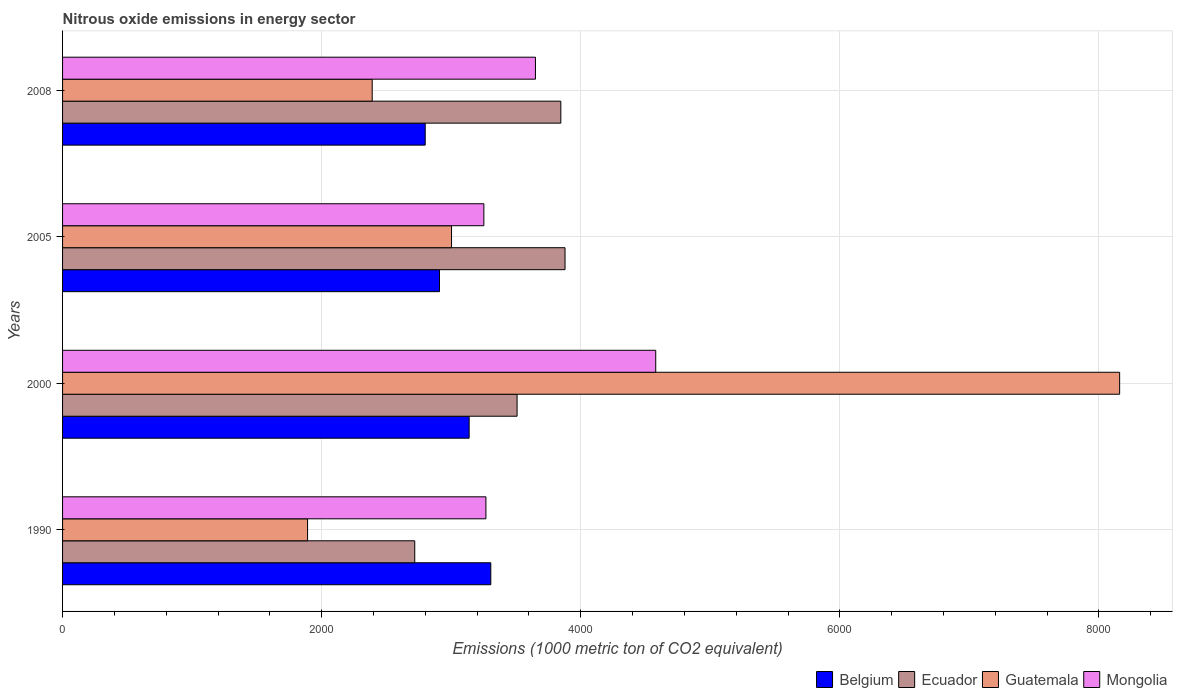How many different coloured bars are there?
Your answer should be compact. 4. How many groups of bars are there?
Provide a short and direct response. 4. Are the number of bars on each tick of the Y-axis equal?
Your response must be concise. Yes. How many bars are there on the 1st tick from the top?
Your answer should be compact. 4. What is the amount of nitrous oxide emitted in Mongolia in 2008?
Keep it short and to the point. 3650.1. Across all years, what is the maximum amount of nitrous oxide emitted in Ecuador?
Provide a short and direct response. 3878.5. Across all years, what is the minimum amount of nitrous oxide emitted in Ecuador?
Ensure brevity in your answer.  2718.5. In which year was the amount of nitrous oxide emitted in Belgium maximum?
Keep it short and to the point. 1990. In which year was the amount of nitrous oxide emitted in Mongolia minimum?
Offer a very short reply. 2005. What is the total amount of nitrous oxide emitted in Belgium in the graph?
Offer a very short reply. 1.22e+04. What is the difference between the amount of nitrous oxide emitted in Mongolia in 1990 and that in 2005?
Provide a short and direct response. 15.9. What is the difference between the amount of nitrous oxide emitted in Ecuador in 2005 and the amount of nitrous oxide emitted in Guatemala in 2000?
Offer a very short reply. -4280.9. What is the average amount of nitrous oxide emitted in Guatemala per year?
Your answer should be compact. 3860.75. In the year 2005, what is the difference between the amount of nitrous oxide emitted in Belgium and amount of nitrous oxide emitted in Guatemala?
Ensure brevity in your answer.  -93. What is the ratio of the amount of nitrous oxide emitted in Guatemala in 2000 to that in 2005?
Provide a succinct answer. 2.72. What is the difference between the highest and the second highest amount of nitrous oxide emitted in Mongolia?
Keep it short and to the point. 928.5. What is the difference between the highest and the lowest amount of nitrous oxide emitted in Guatemala?
Your answer should be compact. 6268.2. Is the sum of the amount of nitrous oxide emitted in Ecuador in 1990 and 2005 greater than the maximum amount of nitrous oxide emitted in Belgium across all years?
Your response must be concise. Yes. What does the 2nd bar from the top in 2005 represents?
Give a very brief answer. Guatemala. What does the 2nd bar from the bottom in 2008 represents?
Offer a very short reply. Ecuador. How many bars are there?
Your answer should be compact. 16. How many years are there in the graph?
Provide a succinct answer. 4. What is the difference between two consecutive major ticks on the X-axis?
Ensure brevity in your answer.  2000. Where does the legend appear in the graph?
Offer a very short reply. Bottom right. How many legend labels are there?
Make the answer very short. 4. What is the title of the graph?
Offer a terse response. Nitrous oxide emissions in energy sector. Does "Heavily indebted poor countries" appear as one of the legend labels in the graph?
Your answer should be very brief. No. What is the label or title of the X-axis?
Give a very brief answer. Emissions (1000 metric ton of CO2 equivalent). What is the Emissions (1000 metric ton of CO2 equivalent) of Belgium in 1990?
Keep it short and to the point. 3305.4. What is the Emissions (1000 metric ton of CO2 equivalent) of Ecuador in 1990?
Provide a succinct answer. 2718.5. What is the Emissions (1000 metric ton of CO2 equivalent) in Guatemala in 1990?
Your answer should be compact. 1891.2. What is the Emissions (1000 metric ton of CO2 equivalent) of Mongolia in 1990?
Your answer should be very brief. 3267.8. What is the Emissions (1000 metric ton of CO2 equivalent) in Belgium in 2000?
Ensure brevity in your answer.  3138.4. What is the Emissions (1000 metric ton of CO2 equivalent) of Ecuador in 2000?
Offer a very short reply. 3508.3. What is the Emissions (1000 metric ton of CO2 equivalent) of Guatemala in 2000?
Your response must be concise. 8159.4. What is the Emissions (1000 metric ton of CO2 equivalent) in Mongolia in 2000?
Your answer should be compact. 4578.6. What is the Emissions (1000 metric ton of CO2 equivalent) in Belgium in 2005?
Keep it short and to the point. 2909.4. What is the Emissions (1000 metric ton of CO2 equivalent) in Ecuador in 2005?
Keep it short and to the point. 3878.5. What is the Emissions (1000 metric ton of CO2 equivalent) of Guatemala in 2005?
Your response must be concise. 3002.4. What is the Emissions (1000 metric ton of CO2 equivalent) of Mongolia in 2005?
Keep it short and to the point. 3251.9. What is the Emissions (1000 metric ton of CO2 equivalent) of Belgium in 2008?
Your answer should be very brief. 2799.3. What is the Emissions (1000 metric ton of CO2 equivalent) in Ecuador in 2008?
Offer a very short reply. 3846. What is the Emissions (1000 metric ton of CO2 equivalent) in Guatemala in 2008?
Your answer should be very brief. 2390. What is the Emissions (1000 metric ton of CO2 equivalent) in Mongolia in 2008?
Your answer should be very brief. 3650.1. Across all years, what is the maximum Emissions (1000 metric ton of CO2 equivalent) in Belgium?
Offer a terse response. 3305.4. Across all years, what is the maximum Emissions (1000 metric ton of CO2 equivalent) of Ecuador?
Make the answer very short. 3878.5. Across all years, what is the maximum Emissions (1000 metric ton of CO2 equivalent) of Guatemala?
Your response must be concise. 8159.4. Across all years, what is the maximum Emissions (1000 metric ton of CO2 equivalent) of Mongolia?
Your answer should be compact. 4578.6. Across all years, what is the minimum Emissions (1000 metric ton of CO2 equivalent) of Belgium?
Your answer should be very brief. 2799.3. Across all years, what is the minimum Emissions (1000 metric ton of CO2 equivalent) in Ecuador?
Offer a terse response. 2718.5. Across all years, what is the minimum Emissions (1000 metric ton of CO2 equivalent) in Guatemala?
Your answer should be very brief. 1891.2. Across all years, what is the minimum Emissions (1000 metric ton of CO2 equivalent) in Mongolia?
Your answer should be very brief. 3251.9. What is the total Emissions (1000 metric ton of CO2 equivalent) of Belgium in the graph?
Ensure brevity in your answer.  1.22e+04. What is the total Emissions (1000 metric ton of CO2 equivalent) in Ecuador in the graph?
Provide a short and direct response. 1.40e+04. What is the total Emissions (1000 metric ton of CO2 equivalent) in Guatemala in the graph?
Make the answer very short. 1.54e+04. What is the total Emissions (1000 metric ton of CO2 equivalent) of Mongolia in the graph?
Provide a short and direct response. 1.47e+04. What is the difference between the Emissions (1000 metric ton of CO2 equivalent) in Belgium in 1990 and that in 2000?
Provide a succinct answer. 167. What is the difference between the Emissions (1000 metric ton of CO2 equivalent) of Ecuador in 1990 and that in 2000?
Give a very brief answer. -789.8. What is the difference between the Emissions (1000 metric ton of CO2 equivalent) of Guatemala in 1990 and that in 2000?
Your answer should be very brief. -6268.2. What is the difference between the Emissions (1000 metric ton of CO2 equivalent) in Mongolia in 1990 and that in 2000?
Provide a short and direct response. -1310.8. What is the difference between the Emissions (1000 metric ton of CO2 equivalent) in Belgium in 1990 and that in 2005?
Offer a terse response. 396. What is the difference between the Emissions (1000 metric ton of CO2 equivalent) of Ecuador in 1990 and that in 2005?
Provide a short and direct response. -1160. What is the difference between the Emissions (1000 metric ton of CO2 equivalent) of Guatemala in 1990 and that in 2005?
Your answer should be very brief. -1111.2. What is the difference between the Emissions (1000 metric ton of CO2 equivalent) of Mongolia in 1990 and that in 2005?
Your answer should be very brief. 15.9. What is the difference between the Emissions (1000 metric ton of CO2 equivalent) in Belgium in 1990 and that in 2008?
Your answer should be very brief. 506.1. What is the difference between the Emissions (1000 metric ton of CO2 equivalent) of Ecuador in 1990 and that in 2008?
Offer a very short reply. -1127.5. What is the difference between the Emissions (1000 metric ton of CO2 equivalent) in Guatemala in 1990 and that in 2008?
Ensure brevity in your answer.  -498.8. What is the difference between the Emissions (1000 metric ton of CO2 equivalent) of Mongolia in 1990 and that in 2008?
Your response must be concise. -382.3. What is the difference between the Emissions (1000 metric ton of CO2 equivalent) in Belgium in 2000 and that in 2005?
Ensure brevity in your answer.  229. What is the difference between the Emissions (1000 metric ton of CO2 equivalent) of Ecuador in 2000 and that in 2005?
Offer a very short reply. -370.2. What is the difference between the Emissions (1000 metric ton of CO2 equivalent) of Guatemala in 2000 and that in 2005?
Give a very brief answer. 5157. What is the difference between the Emissions (1000 metric ton of CO2 equivalent) of Mongolia in 2000 and that in 2005?
Your answer should be very brief. 1326.7. What is the difference between the Emissions (1000 metric ton of CO2 equivalent) of Belgium in 2000 and that in 2008?
Your response must be concise. 339.1. What is the difference between the Emissions (1000 metric ton of CO2 equivalent) in Ecuador in 2000 and that in 2008?
Your response must be concise. -337.7. What is the difference between the Emissions (1000 metric ton of CO2 equivalent) of Guatemala in 2000 and that in 2008?
Keep it short and to the point. 5769.4. What is the difference between the Emissions (1000 metric ton of CO2 equivalent) of Mongolia in 2000 and that in 2008?
Offer a terse response. 928.5. What is the difference between the Emissions (1000 metric ton of CO2 equivalent) of Belgium in 2005 and that in 2008?
Offer a terse response. 110.1. What is the difference between the Emissions (1000 metric ton of CO2 equivalent) in Ecuador in 2005 and that in 2008?
Give a very brief answer. 32.5. What is the difference between the Emissions (1000 metric ton of CO2 equivalent) of Guatemala in 2005 and that in 2008?
Give a very brief answer. 612.4. What is the difference between the Emissions (1000 metric ton of CO2 equivalent) of Mongolia in 2005 and that in 2008?
Provide a succinct answer. -398.2. What is the difference between the Emissions (1000 metric ton of CO2 equivalent) in Belgium in 1990 and the Emissions (1000 metric ton of CO2 equivalent) in Ecuador in 2000?
Your answer should be very brief. -202.9. What is the difference between the Emissions (1000 metric ton of CO2 equivalent) of Belgium in 1990 and the Emissions (1000 metric ton of CO2 equivalent) of Guatemala in 2000?
Offer a very short reply. -4854. What is the difference between the Emissions (1000 metric ton of CO2 equivalent) in Belgium in 1990 and the Emissions (1000 metric ton of CO2 equivalent) in Mongolia in 2000?
Ensure brevity in your answer.  -1273.2. What is the difference between the Emissions (1000 metric ton of CO2 equivalent) of Ecuador in 1990 and the Emissions (1000 metric ton of CO2 equivalent) of Guatemala in 2000?
Your answer should be very brief. -5440.9. What is the difference between the Emissions (1000 metric ton of CO2 equivalent) of Ecuador in 1990 and the Emissions (1000 metric ton of CO2 equivalent) of Mongolia in 2000?
Provide a succinct answer. -1860.1. What is the difference between the Emissions (1000 metric ton of CO2 equivalent) in Guatemala in 1990 and the Emissions (1000 metric ton of CO2 equivalent) in Mongolia in 2000?
Offer a terse response. -2687.4. What is the difference between the Emissions (1000 metric ton of CO2 equivalent) of Belgium in 1990 and the Emissions (1000 metric ton of CO2 equivalent) of Ecuador in 2005?
Give a very brief answer. -573.1. What is the difference between the Emissions (1000 metric ton of CO2 equivalent) of Belgium in 1990 and the Emissions (1000 metric ton of CO2 equivalent) of Guatemala in 2005?
Offer a terse response. 303. What is the difference between the Emissions (1000 metric ton of CO2 equivalent) of Belgium in 1990 and the Emissions (1000 metric ton of CO2 equivalent) of Mongolia in 2005?
Your response must be concise. 53.5. What is the difference between the Emissions (1000 metric ton of CO2 equivalent) in Ecuador in 1990 and the Emissions (1000 metric ton of CO2 equivalent) in Guatemala in 2005?
Make the answer very short. -283.9. What is the difference between the Emissions (1000 metric ton of CO2 equivalent) of Ecuador in 1990 and the Emissions (1000 metric ton of CO2 equivalent) of Mongolia in 2005?
Keep it short and to the point. -533.4. What is the difference between the Emissions (1000 metric ton of CO2 equivalent) in Guatemala in 1990 and the Emissions (1000 metric ton of CO2 equivalent) in Mongolia in 2005?
Offer a terse response. -1360.7. What is the difference between the Emissions (1000 metric ton of CO2 equivalent) in Belgium in 1990 and the Emissions (1000 metric ton of CO2 equivalent) in Ecuador in 2008?
Offer a terse response. -540.6. What is the difference between the Emissions (1000 metric ton of CO2 equivalent) in Belgium in 1990 and the Emissions (1000 metric ton of CO2 equivalent) in Guatemala in 2008?
Offer a terse response. 915.4. What is the difference between the Emissions (1000 metric ton of CO2 equivalent) of Belgium in 1990 and the Emissions (1000 metric ton of CO2 equivalent) of Mongolia in 2008?
Provide a succinct answer. -344.7. What is the difference between the Emissions (1000 metric ton of CO2 equivalent) of Ecuador in 1990 and the Emissions (1000 metric ton of CO2 equivalent) of Guatemala in 2008?
Ensure brevity in your answer.  328.5. What is the difference between the Emissions (1000 metric ton of CO2 equivalent) of Ecuador in 1990 and the Emissions (1000 metric ton of CO2 equivalent) of Mongolia in 2008?
Your answer should be very brief. -931.6. What is the difference between the Emissions (1000 metric ton of CO2 equivalent) of Guatemala in 1990 and the Emissions (1000 metric ton of CO2 equivalent) of Mongolia in 2008?
Provide a short and direct response. -1758.9. What is the difference between the Emissions (1000 metric ton of CO2 equivalent) of Belgium in 2000 and the Emissions (1000 metric ton of CO2 equivalent) of Ecuador in 2005?
Provide a succinct answer. -740.1. What is the difference between the Emissions (1000 metric ton of CO2 equivalent) of Belgium in 2000 and the Emissions (1000 metric ton of CO2 equivalent) of Guatemala in 2005?
Offer a very short reply. 136. What is the difference between the Emissions (1000 metric ton of CO2 equivalent) in Belgium in 2000 and the Emissions (1000 metric ton of CO2 equivalent) in Mongolia in 2005?
Provide a short and direct response. -113.5. What is the difference between the Emissions (1000 metric ton of CO2 equivalent) of Ecuador in 2000 and the Emissions (1000 metric ton of CO2 equivalent) of Guatemala in 2005?
Your answer should be compact. 505.9. What is the difference between the Emissions (1000 metric ton of CO2 equivalent) of Ecuador in 2000 and the Emissions (1000 metric ton of CO2 equivalent) of Mongolia in 2005?
Provide a succinct answer. 256.4. What is the difference between the Emissions (1000 metric ton of CO2 equivalent) in Guatemala in 2000 and the Emissions (1000 metric ton of CO2 equivalent) in Mongolia in 2005?
Your answer should be compact. 4907.5. What is the difference between the Emissions (1000 metric ton of CO2 equivalent) of Belgium in 2000 and the Emissions (1000 metric ton of CO2 equivalent) of Ecuador in 2008?
Provide a succinct answer. -707.6. What is the difference between the Emissions (1000 metric ton of CO2 equivalent) in Belgium in 2000 and the Emissions (1000 metric ton of CO2 equivalent) in Guatemala in 2008?
Your response must be concise. 748.4. What is the difference between the Emissions (1000 metric ton of CO2 equivalent) of Belgium in 2000 and the Emissions (1000 metric ton of CO2 equivalent) of Mongolia in 2008?
Offer a terse response. -511.7. What is the difference between the Emissions (1000 metric ton of CO2 equivalent) in Ecuador in 2000 and the Emissions (1000 metric ton of CO2 equivalent) in Guatemala in 2008?
Offer a terse response. 1118.3. What is the difference between the Emissions (1000 metric ton of CO2 equivalent) of Ecuador in 2000 and the Emissions (1000 metric ton of CO2 equivalent) of Mongolia in 2008?
Give a very brief answer. -141.8. What is the difference between the Emissions (1000 metric ton of CO2 equivalent) of Guatemala in 2000 and the Emissions (1000 metric ton of CO2 equivalent) of Mongolia in 2008?
Offer a very short reply. 4509.3. What is the difference between the Emissions (1000 metric ton of CO2 equivalent) in Belgium in 2005 and the Emissions (1000 metric ton of CO2 equivalent) in Ecuador in 2008?
Your answer should be compact. -936.6. What is the difference between the Emissions (1000 metric ton of CO2 equivalent) of Belgium in 2005 and the Emissions (1000 metric ton of CO2 equivalent) of Guatemala in 2008?
Give a very brief answer. 519.4. What is the difference between the Emissions (1000 metric ton of CO2 equivalent) in Belgium in 2005 and the Emissions (1000 metric ton of CO2 equivalent) in Mongolia in 2008?
Your answer should be compact. -740.7. What is the difference between the Emissions (1000 metric ton of CO2 equivalent) in Ecuador in 2005 and the Emissions (1000 metric ton of CO2 equivalent) in Guatemala in 2008?
Your answer should be very brief. 1488.5. What is the difference between the Emissions (1000 metric ton of CO2 equivalent) of Ecuador in 2005 and the Emissions (1000 metric ton of CO2 equivalent) of Mongolia in 2008?
Ensure brevity in your answer.  228.4. What is the difference between the Emissions (1000 metric ton of CO2 equivalent) in Guatemala in 2005 and the Emissions (1000 metric ton of CO2 equivalent) in Mongolia in 2008?
Ensure brevity in your answer.  -647.7. What is the average Emissions (1000 metric ton of CO2 equivalent) of Belgium per year?
Provide a short and direct response. 3038.12. What is the average Emissions (1000 metric ton of CO2 equivalent) of Ecuador per year?
Provide a short and direct response. 3487.82. What is the average Emissions (1000 metric ton of CO2 equivalent) in Guatemala per year?
Provide a succinct answer. 3860.75. What is the average Emissions (1000 metric ton of CO2 equivalent) in Mongolia per year?
Keep it short and to the point. 3687.1. In the year 1990, what is the difference between the Emissions (1000 metric ton of CO2 equivalent) of Belgium and Emissions (1000 metric ton of CO2 equivalent) of Ecuador?
Make the answer very short. 586.9. In the year 1990, what is the difference between the Emissions (1000 metric ton of CO2 equivalent) in Belgium and Emissions (1000 metric ton of CO2 equivalent) in Guatemala?
Your answer should be very brief. 1414.2. In the year 1990, what is the difference between the Emissions (1000 metric ton of CO2 equivalent) of Belgium and Emissions (1000 metric ton of CO2 equivalent) of Mongolia?
Give a very brief answer. 37.6. In the year 1990, what is the difference between the Emissions (1000 metric ton of CO2 equivalent) of Ecuador and Emissions (1000 metric ton of CO2 equivalent) of Guatemala?
Make the answer very short. 827.3. In the year 1990, what is the difference between the Emissions (1000 metric ton of CO2 equivalent) of Ecuador and Emissions (1000 metric ton of CO2 equivalent) of Mongolia?
Ensure brevity in your answer.  -549.3. In the year 1990, what is the difference between the Emissions (1000 metric ton of CO2 equivalent) of Guatemala and Emissions (1000 metric ton of CO2 equivalent) of Mongolia?
Your response must be concise. -1376.6. In the year 2000, what is the difference between the Emissions (1000 metric ton of CO2 equivalent) of Belgium and Emissions (1000 metric ton of CO2 equivalent) of Ecuador?
Make the answer very short. -369.9. In the year 2000, what is the difference between the Emissions (1000 metric ton of CO2 equivalent) of Belgium and Emissions (1000 metric ton of CO2 equivalent) of Guatemala?
Ensure brevity in your answer.  -5021. In the year 2000, what is the difference between the Emissions (1000 metric ton of CO2 equivalent) in Belgium and Emissions (1000 metric ton of CO2 equivalent) in Mongolia?
Ensure brevity in your answer.  -1440.2. In the year 2000, what is the difference between the Emissions (1000 metric ton of CO2 equivalent) in Ecuador and Emissions (1000 metric ton of CO2 equivalent) in Guatemala?
Offer a very short reply. -4651.1. In the year 2000, what is the difference between the Emissions (1000 metric ton of CO2 equivalent) of Ecuador and Emissions (1000 metric ton of CO2 equivalent) of Mongolia?
Give a very brief answer. -1070.3. In the year 2000, what is the difference between the Emissions (1000 metric ton of CO2 equivalent) of Guatemala and Emissions (1000 metric ton of CO2 equivalent) of Mongolia?
Your answer should be very brief. 3580.8. In the year 2005, what is the difference between the Emissions (1000 metric ton of CO2 equivalent) in Belgium and Emissions (1000 metric ton of CO2 equivalent) in Ecuador?
Give a very brief answer. -969.1. In the year 2005, what is the difference between the Emissions (1000 metric ton of CO2 equivalent) in Belgium and Emissions (1000 metric ton of CO2 equivalent) in Guatemala?
Offer a terse response. -93. In the year 2005, what is the difference between the Emissions (1000 metric ton of CO2 equivalent) in Belgium and Emissions (1000 metric ton of CO2 equivalent) in Mongolia?
Your answer should be compact. -342.5. In the year 2005, what is the difference between the Emissions (1000 metric ton of CO2 equivalent) of Ecuador and Emissions (1000 metric ton of CO2 equivalent) of Guatemala?
Give a very brief answer. 876.1. In the year 2005, what is the difference between the Emissions (1000 metric ton of CO2 equivalent) in Ecuador and Emissions (1000 metric ton of CO2 equivalent) in Mongolia?
Provide a succinct answer. 626.6. In the year 2005, what is the difference between the Emissions (1000 metric ton of CO2 equivalent) in Guatemala and Emissions (1000 metric ton of CO2 equivalent) in Mongolia?
Provide a succinct answer. -249.5. In the year 2008, what is the difference between the Emissions (1000 metric ton of CO2 equivalent) in Belgium and Emissions (1000 metric ton of CO2 equivalent) in Ecuador?
Make the answer very short. -1046.7. In the year 2008, what is the difference between the Emissions (1000 metric ton of CO2 equivalent) in Belgium and Emissions (1000 metric ton of CO2 equivalent) in Guatemala?
Your answer should be very brief. 409.3. In the year 2008, what is the difference between the Emissions (1000 metric ton of CO2 equivalent) of Belgium and Emissions (1000 metric ton of CO2 equivalent) of Mongolia?
Ensure brevity in your answer.  -850.8. In the year 2008, what is the difference between the Emissions (1000 metric ton of CO2 equivalent) of Ecuador and Emissions (1000 metric ton of CO2 equivalent) of Guatemala?
Provide a succinct answer. 1456. In the year 2008, what is the difference between the Emissions (1000 metric ton of CO2 equivalent) in Ecuador and Emissions (1000 metric ton of CO2 equivalent) in Mongolia?
Your answer should be compact. 195.9. In the year 2008, what is the difference between the Emissions (1000 metric ton of CO2 equivalent) of Guatemala and Emissions (1000 metric ton of CO2 equivalent) of Mongolia?
Your answer should be very brief. -1260.1. What is the ratio of the Emissions (1000 metric ton of CO2 equivalent) in Belgium in 1990 to that in 2000?
Your response must be concise. 1.05. What is the ratio of the Emissions (1000 metric ton of CO2 equivalent) of Ecuador in 1990 to that in 2000?
Offer a terse response. 0.77. What is the ratio of the Emissions (1000 metric ton of CO2 equivalent) in Guatemala in 1990 to that in 2000?
Your response must be concise. 0.23. What is the ratio of the Emissions (1000 metric ton of CO2 equivalent) of Mongolia in 1990 to that in 2000?
Provide a short and direct response. 0.71. What is the ratio of the Emissions (1000 metric ton of CO2 equivalent) of Belgium in 1990 to that in 2005?
Make the answer very short. 1.14. What is the ratio of the Emissions (1000 metric ton of CO2 equivalent) of Ecuador in 1990 to that in 2005?
Make the answer very short. 0.7. What is the ratio of the Emissions (1000 metric ton of CO2 equivalent) of Guatemala in 1990 to that in 2005?
Provide a succinct answer. 0.63. What is the ratio of the Emissions (1000 metric ton of CO2 equivalent) of Mongolia in 1990 to that in 2005?
Your answer should be compact. 1. What is the ratio of the Emissions (1000 metric ton of CO2 equivalent) in Belgium in 1990 to that in 2008?
Provide a succinct answer. 1.18. What is the ratio of the Emissions (1000 metric ton of CO2 equivalent) in Ecuador in 1990 to that in 2008?
Make the answer very short. 0.71. What is the ratio of the Emissions (1000 metric ton of CO2 equivalent) in Guatemala in 1990 to that in 2008?
Offer a terse response. 0.79. What is the ratio of the Emissions (1000 metric ton of CO2 equivalent) in Mongolia in 1990 to that in 2008?
Keep it short and to the point. 0.9. What is the ratio of the Emissions (1000 metric ton of CO2 equivalent) in Belgium in 2000 to that in 2005?
Provide a succinct answer. 1.08. What is the ratio of the Emissions (1000 metric ton of CO2 equivalent) in Ecuador in 2000 to that in 2005?
Give a very brief answer. 0.9. What is the ratio of the Emissions (1000 metric ton of CO2 equivalent) in Guatemala in 2000 to that in 2005?
Keep it short and to the point. 2.72. What is the ratio of the Emissions (1000 metric ton of CO2 equivalent) of Mongolia in 2000 to that in 2005?
Offer a very short reply. 1.41. What is the ratio of the Emissions (1000 metric ton of CO2 equivalent) of Belgium in 2000 to that in 2008?
Your answer should be very brief. 1.12. What is the ratio of the Emissions (1000 metric ton of CO2 equivalent) of Ecuador in 2000 to that in 2008?
Your response must be concise. 0.91. What is the ratio of the Emissions (1000 metric ton of CO2 equivalent) in Guatemala in 2000 to that in 2008?
Your response must be concise. 3.41. What is the ratio of the Emissions (1000 metric ton of CO2 equivalent) in Mongolia in 2000 to that in 2008?
Give a very brief answer. 1.25. What is the ratio of the Emissions (1000 metric ton of CO2 equivalent) in Belgium in 2005 to that in 2008?
Provide a succinct answer. 1.04. What is the ratio of the Emissions (1000 metric ton of CO2 equivalent) in Ecuador in 2005 to that in 2008?
Keep it short and to the point. 1.01. What is the ratio of the Emissions (1000 metric ton of CO2 equivalent) of Guatemala in 2005 to that in 2008?
Offer a terse response. 1.26. What is the ratio of the Emissions (1000 metric ton of CO2 equivalent) of Mongolia in 2005 to that in 2008?
Offer a very short reply. 0.89. What is the difference between the highest and the second highest Emissions (1000 metric ton of CO2 equivalent) of Belgium?
Provide a succinct answer. 167. What is the difference between the highest and the second highest Emissions (1000 metric ton of CO2 equivalent) of Ecuador?
Provide a succinct answer. 32.5. What is the difference between the highest and the second highest Emissions (1000 metric ton of CO2 equivalent) of Guatemala?
Your answer should be very brief. 5157. What is the difference between the highest and the second highest Emissions (1000 metric ton of CO2 equivalent) of Mongolia?
Provide a succinct answer. 928.5. What is the difference between the highest and the lowest Emissions (1000 metric ton of CO2 equivalent) of Belgium?
Your answer should be very brief. 506.1. What is the difference between the highest and the lowest Emissions (1000 metric ton of CO2 equivalent) of Ecuador?
Your response must be concise. 1160. What is the difference between the highest and the lowest Emissions (1000 metric ton of CO2 equivalent) of Guatemala?
Provide a short and direct response. 6268.2. What is the difference between the highest and the lowest Emissions (1000 metric ton of CO2 equivalent) of Mongolia?
Ensure brevity in your answer.  1326.7. 